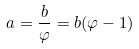Convert formula to latex. <formula><loc_0><loc_0><loc_500><loc_500>a = \frac { b } { \varphi } = b ( \varphi - 1 )</formula> 